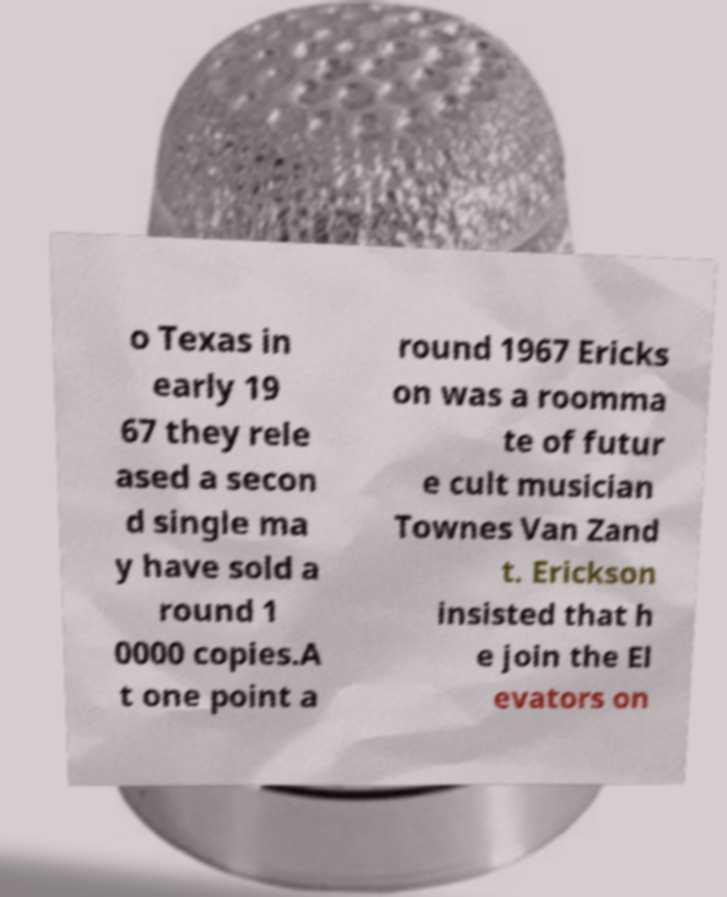For documentation purposes, I need the text within this image transcribed. Could you provide that? o Texas in early 19 67 they rele ased a secon d single ma y have sold a round 1 0000 copies.A t one point a round 1967 Ericks on was a roomma te of futur e cult musician Townes Van Zand t. Erickson insisted that h e join the El evators on 